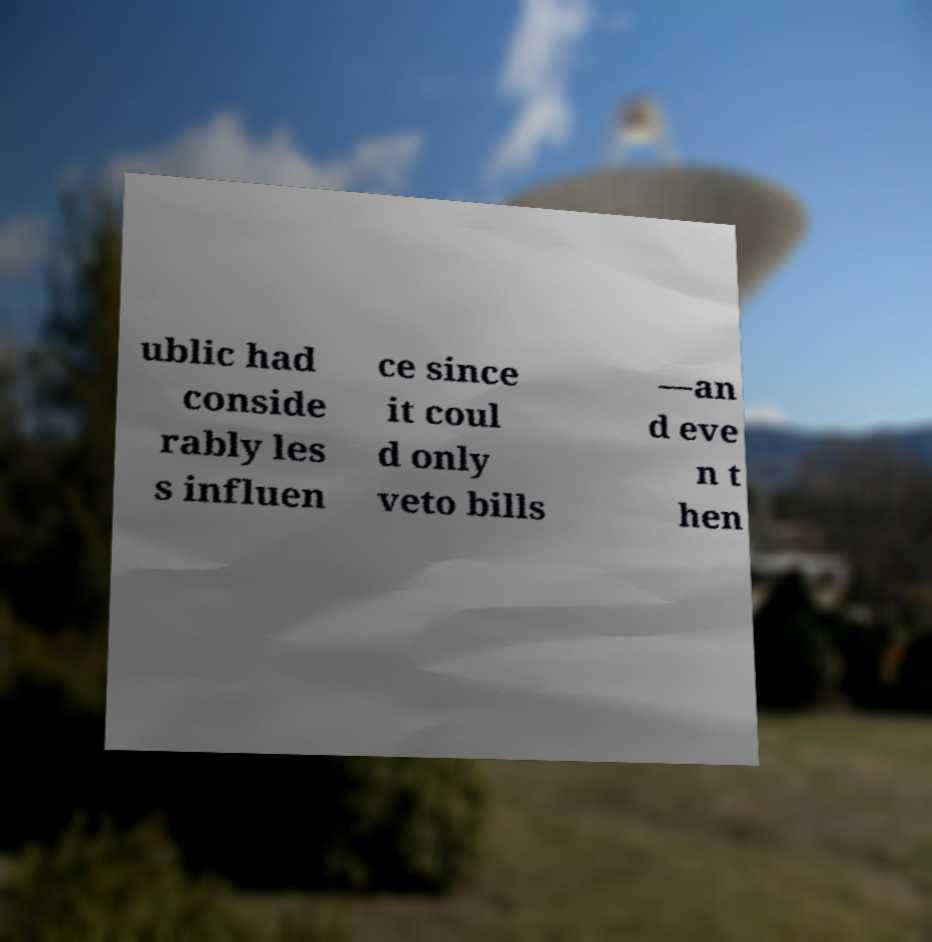What messages or text are displayed in this image? I need them in a readable, typed format. ublic had conside rably les s influen ce since it coul d only veto bills —an d eve n t hen 